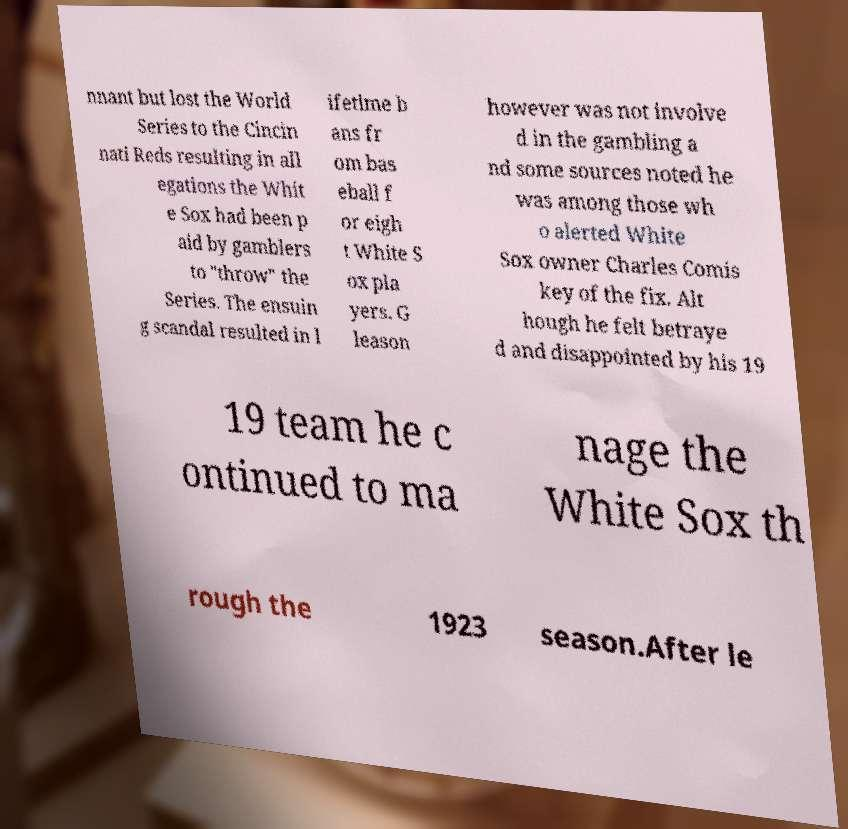Please read and relay the text visible in this image. What does it say? nnant but lost the World Series to the Cincin nati Reds resulting in all egations the Whit e Sox had been p aid by gamblers to "throw" the Series. The ensuin g scandal resulted in l ifetime b ans fr om bas eball f or eigh t White S ox pla yers. G leason however was not involve d in the gambling a nd some sources noted he was among those wh o alerted White Sox owner Charles Comis key of the fix. Alt hough he felt betraye d and disappointed by his 19 19 team he c ontinued to ma nage the White Sox th rough the 1923 season.After le 